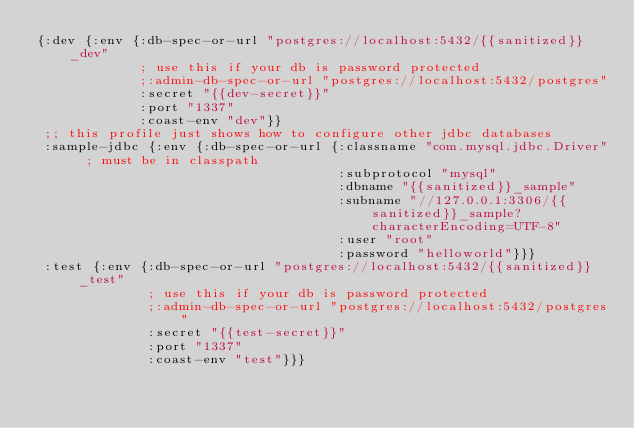Convert code to text. <code><loc_0><loc_0><loc_500><loc_500><_Clojure_>{:dev {:env {:db-spec-or-url "postgres://localhost:5432/{{sanitized}}_dev"
             ; use this if your db is password protected
             ;:admin-db-spec-or-url "postgres://localhost:5432/postgres"
             :secret "{{dev-secret}}"
             :port "1337"
             :coast-env "dev"}}
 ;; this profile just shows how to configure other jdbc databases
 :sample-jdbc {:env {:db-spec-or-url {:classname "com.mysql.jdbc.Driver" ; must be in classpath
                                      :subprotocol "mysql"
                                      :dbname "{{sanitized}}_sample"
                                      :subname "//127.0.0.1:3306/{{sanitized}}_sample?characterEncoding=UTF-8"
                                      :user "root"
                                      :password "helloworld"}}}
 :test {:env {:db-spec-or-url "postgres://localhost:5432/{{sanitized}}_test"
              ; use this if your db is password protected
              ;:admin-db-spec-or-url "postgres://localhost:5432/postgres"
              :secret "{{test-secret}}"
              :port "1337"
              :coast-env "test"}}}
</code> 